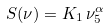Convert formula to latex. <formula><loc_0><loc_0><loc_500><loc_500>S ( \nu ) = K _ { 1 } \, \nu _ { 5 } ^ { \alpha }</formula> 